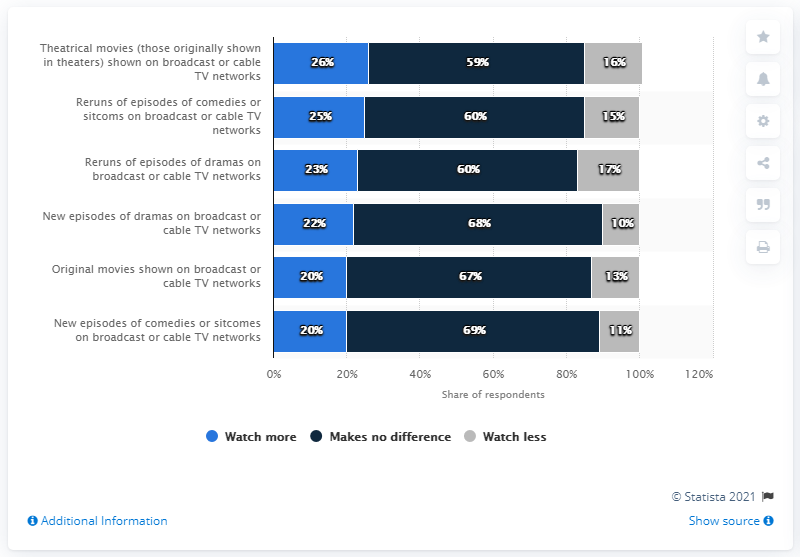Indicate a few pertinent items in this graphic. The difference between the highest light blue bar value and the lowest gray bar value is 16. Watch more original movies on cable TV with a 20% value. 